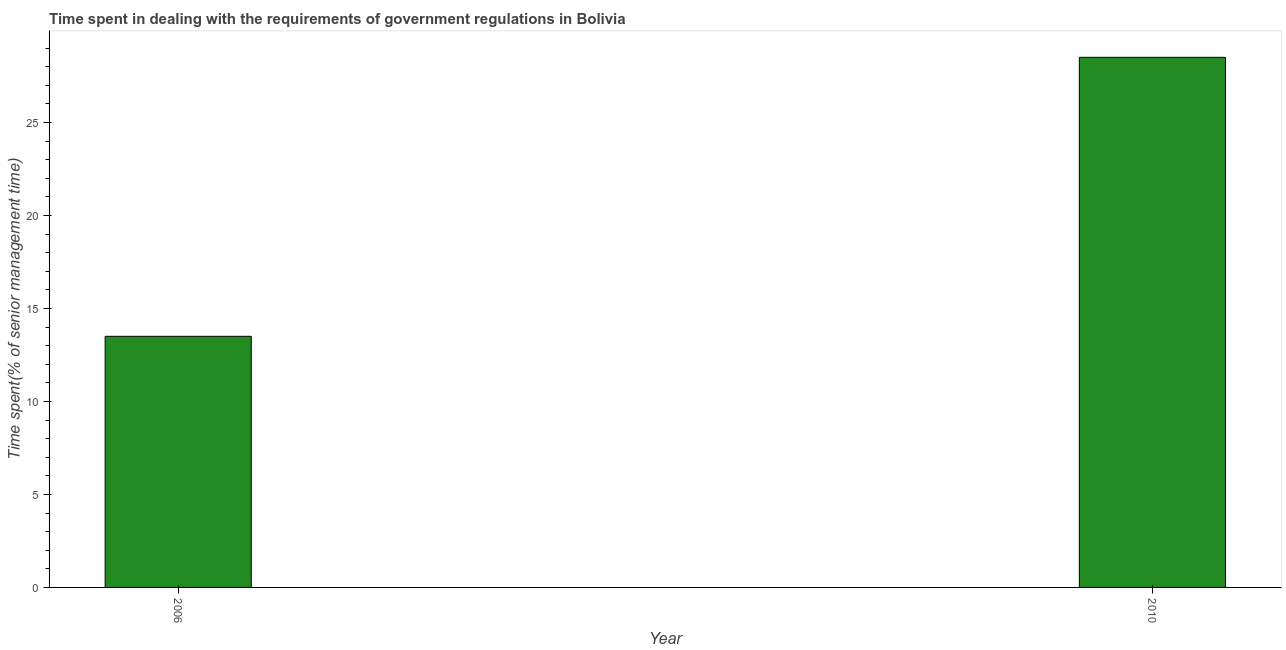Does the graph contain grids?
Give a very brief answer. No. What is the title of the graph?
Your answer should be compact. Time spent in dealing with the requirements of government regulations in Bolivia. What is the label or title of the Y-axis?
Ensure brevity in your answer.  Time spent(% of senior management time). What is the time spent in dealing with government regulations in 2006?
Your answer should be compact. 13.5. Across all years, what is the maximum time spent in dealing with government regulations?
Provide a succinct answer. 28.5. Across all years, what is the minimum time spent in dealing with government regulations?
Give a very brief answer. 13.5. In which year was the time spent in dealing with government regulations maximum?
Offer a terse response. 2010. What is the ratio of the time spent in dealing with government regulations in 2006 to that in 2010?
Your response must be concise. 0.47. Is the time spent in dealing with government regulations in 2006 less than that in 2010?
Give a very brief answer. Yes. In how many years, is the time spent in dealing with government regulations greater than the average time spent in dealing with government regulations taken over all years?
Make the answer very short. 1. How many bars are there?
Ensure brevity in your answer.  2. Are the values on the major ticks of Y-axis written in scientific E-notation?
Ensure brevity in your answer.  No. What is the difference between the Time spent(% of senior management time) in 2006 and 2010?
Keep it short and to the point. -15. What is the ratio of the Time spent(% of senior management time) in 2006 to that in 2010?
Give a very brief answer. 0.47. 